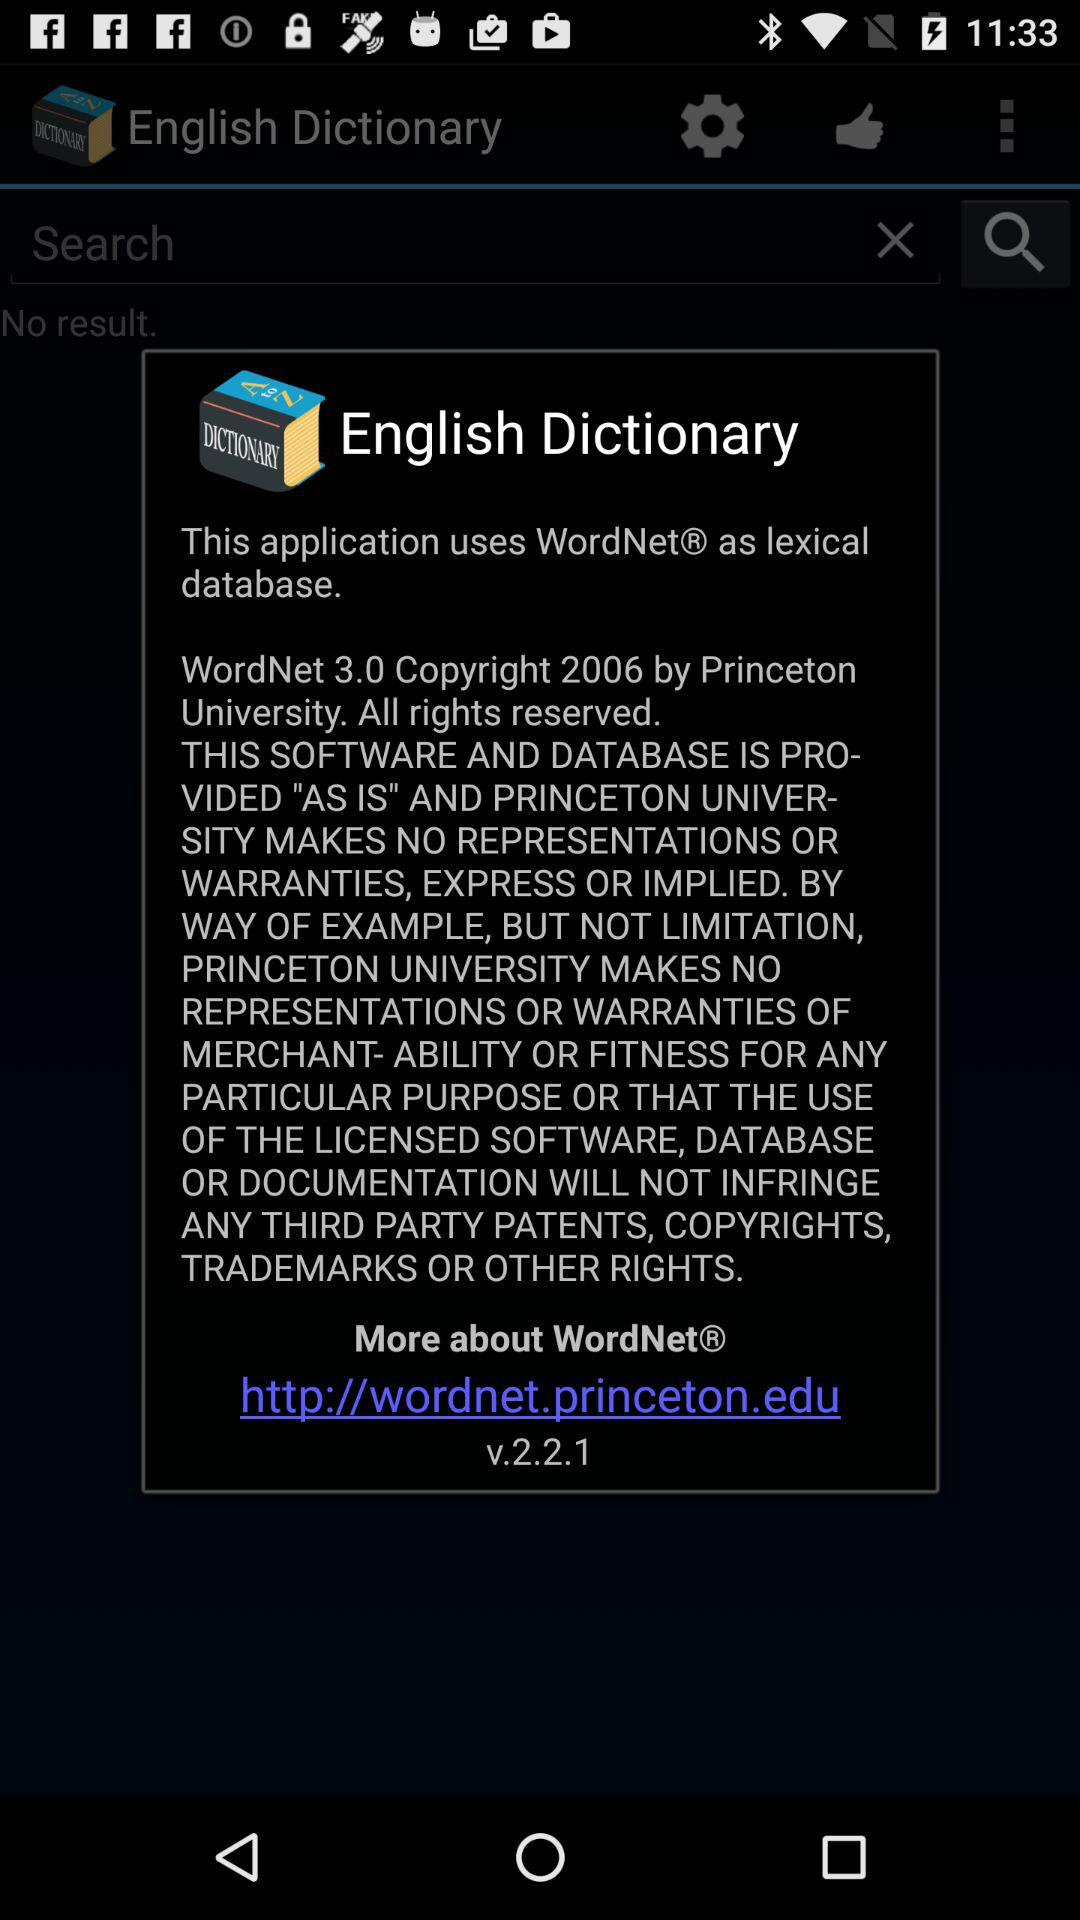What is the version of the "English Dictionary"? The version of the "English Dictionary" is v.2.2.1. 